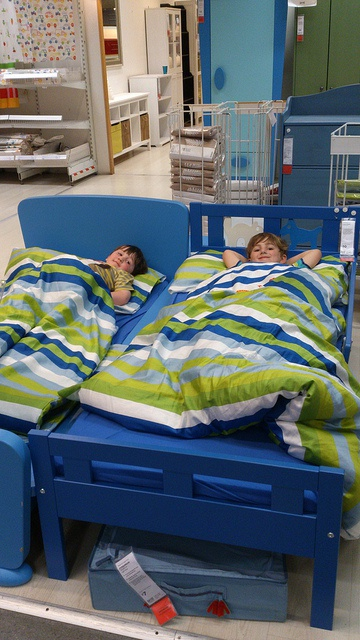Describe the objects in this image and their specific colors. I can see bed in darkgray, navy, black, and blue tones, bed in darkgray, blue, and olive tones, suitcase in darkgray, black, blue, gray, and navy tones, people in darkgray, gray, tan, and maroon tones, and people in darkgray, black, brown, gray, and tan tones in this image. 